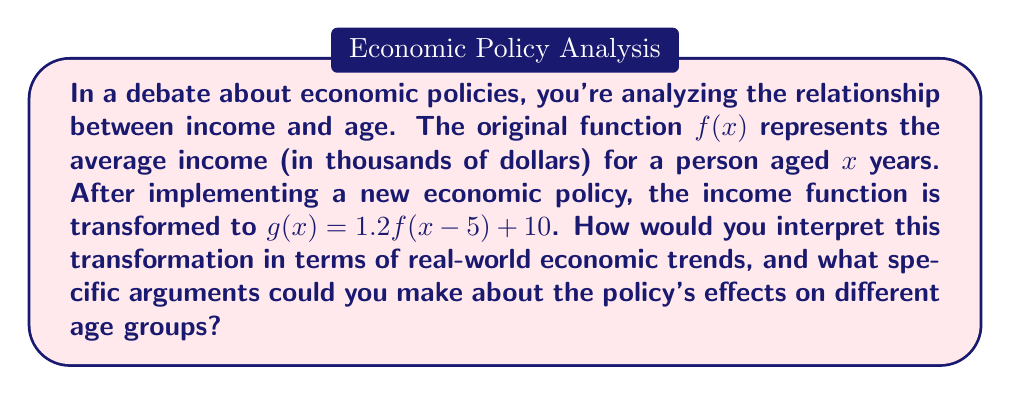Could you help me with this problem? To interpret this transformation, let's break it down step-by-step:

1) The transformation $g(x) = 1.2f(x-5) + 10$ can be understood as a combination of three separate transformations:

   a) $f(x-5)$: A horizontal shift 5 units to the right
   b) $1.2f(x)$: A vertical stretch by a factor of 1.2
   c) $f(x) + 10$: A vertical shift 10 units up

2) Horizontal shift: $f(x-5)$
   This means that the income levels previously associated with age $x$ are now associated with age $x+5$. In economic terms, this suggests that people are reaching income levels 5 years later than before.

3) Vertical stretch: $1.2f(x)$
   This indicates that all income values have been increased by 20%. This could be interpreted as an overall economic growth or inflation effect.

4) Vertical shift: $f(x) + 10$
   This shows a flat increase of $10,000 across all age groups, which could be seen as a universal basic income or a general increase in the minimum wage.

5) Combining these effects:
   - Younger individuals (below the age where the function starts to increase significantly) benefit most from the flat $10,000 increase.
   - Middle-aged individuals see their income levels increase by 20% plus $10,000, but they reach these levels 5 years later than before.
   - Older individuals might not see much benefit if they're past the peak of the income curve, as they're effectively looking at income levels from 5 years prior, albeit with the 20% increase and $10,000 addition.

6) Arguments about the policy's effects:
   - Positive: Overall increase in income across all age groups, potentially reducing poverty.
   - Negative: Delayed career progression, as higher income levels are reached later in life.
   - Debate point: Is the policy more beneficial for younger or older workers? How does it affect intergenerational equity?
Answer: The transformation represents a delay in reaching income levels by 5 years, a 20% overall increase in income, and a flat $10,000 increase across all ages. This suggests the policy has increased overall income but potentially delayed career progression. The effects vary by age group, with younger individuals benefiting most from the flat increase, middle-aged seeing significant growth but delayed, and older individuals potentially seeing less benefit. 